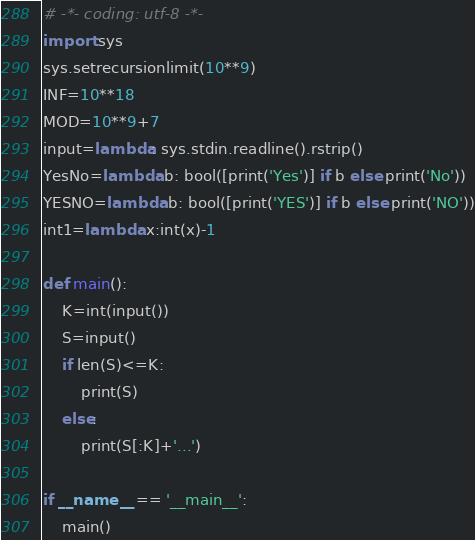<code> <loc_0><loc_0><loc_500><loc_500><_Python_># -*- coding: utf-8 -*-
import sys
sys.setrecursionlimit(10**9)
INF=10**18
MOD=10**9+7
input=lambda: sys.stdin.readline().rstrip()
YesNo=lambda b: bool([print('Yes')] if b else print('No'))
YESNO=lambda b: bool([print('YES')] if b else print('NO'))
int1=lambda x:int(x)-1

def main():
    K=int(input())
    S=input()
    if len(S)<=K:
        print(S)
    else:
        print(S[:K]+'...')

if __name__ == '__main__':
    main()
</code> 